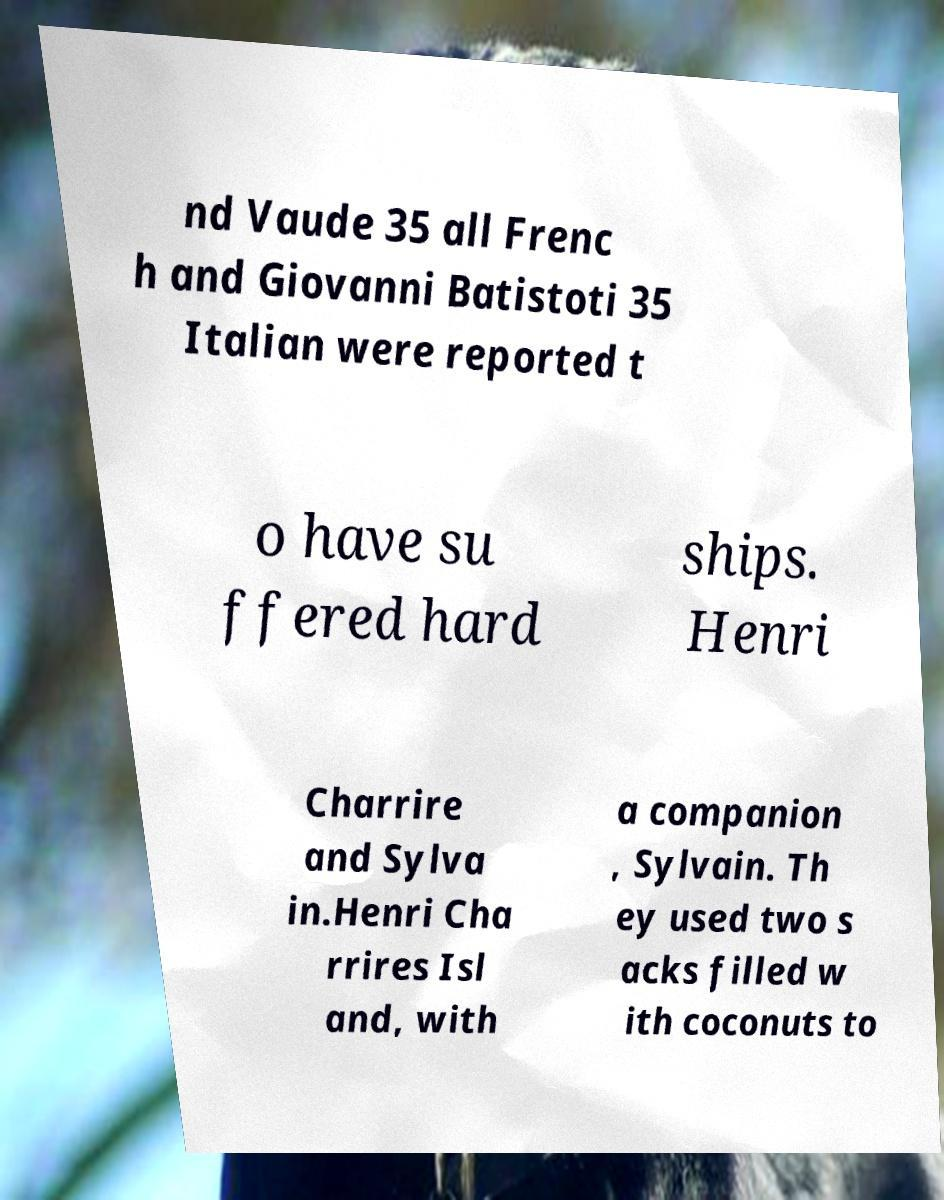What messages or text are displayed in this image? I need them in a readable, typed format. nd Vaude 35 all Frenc h and Giovanni Batistoti 35 Italian were reported t o have su ffered hard ships. Henri Charrire and Sylva in.Henri Cha rrires Isl and, with a companion , Sylvain. Th ey used two s acks filled w ith coconuts to 